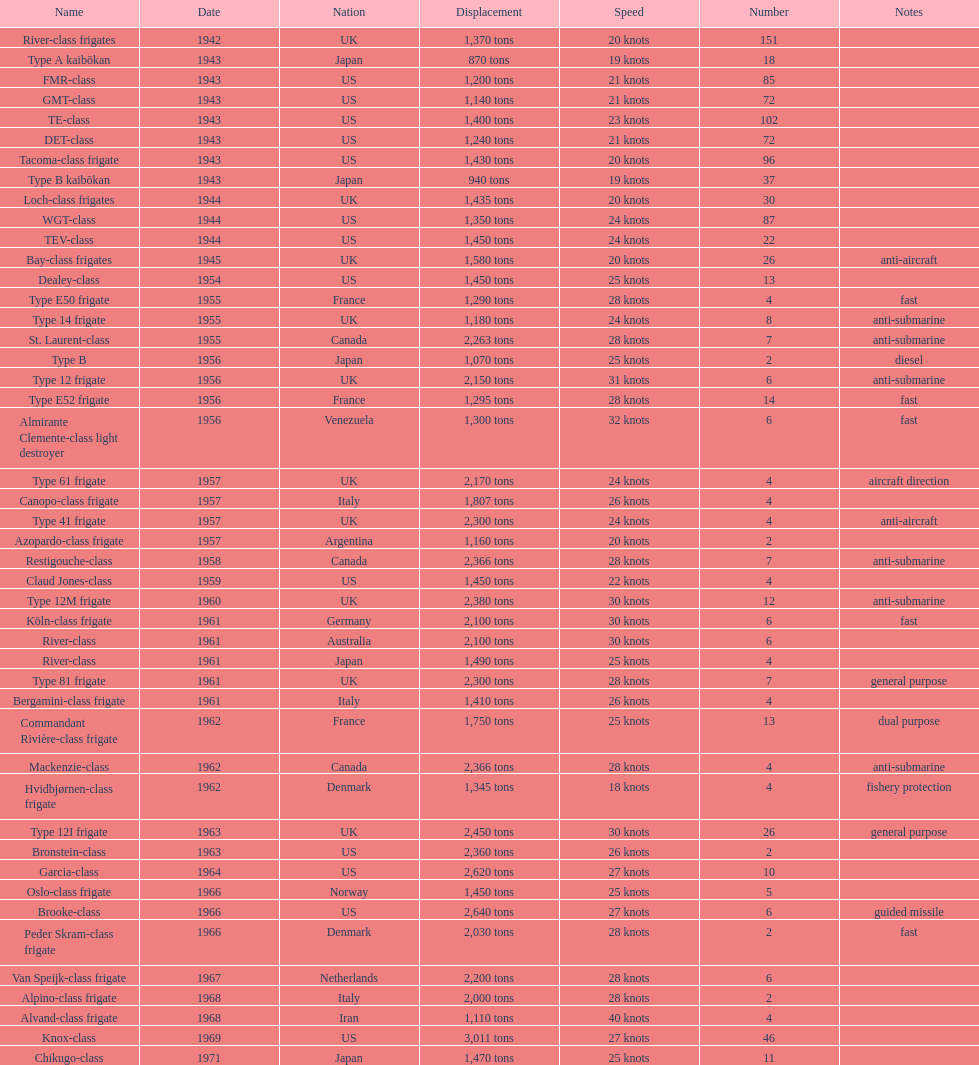What is the amount of displacement in tons for type b? 940 tons. 